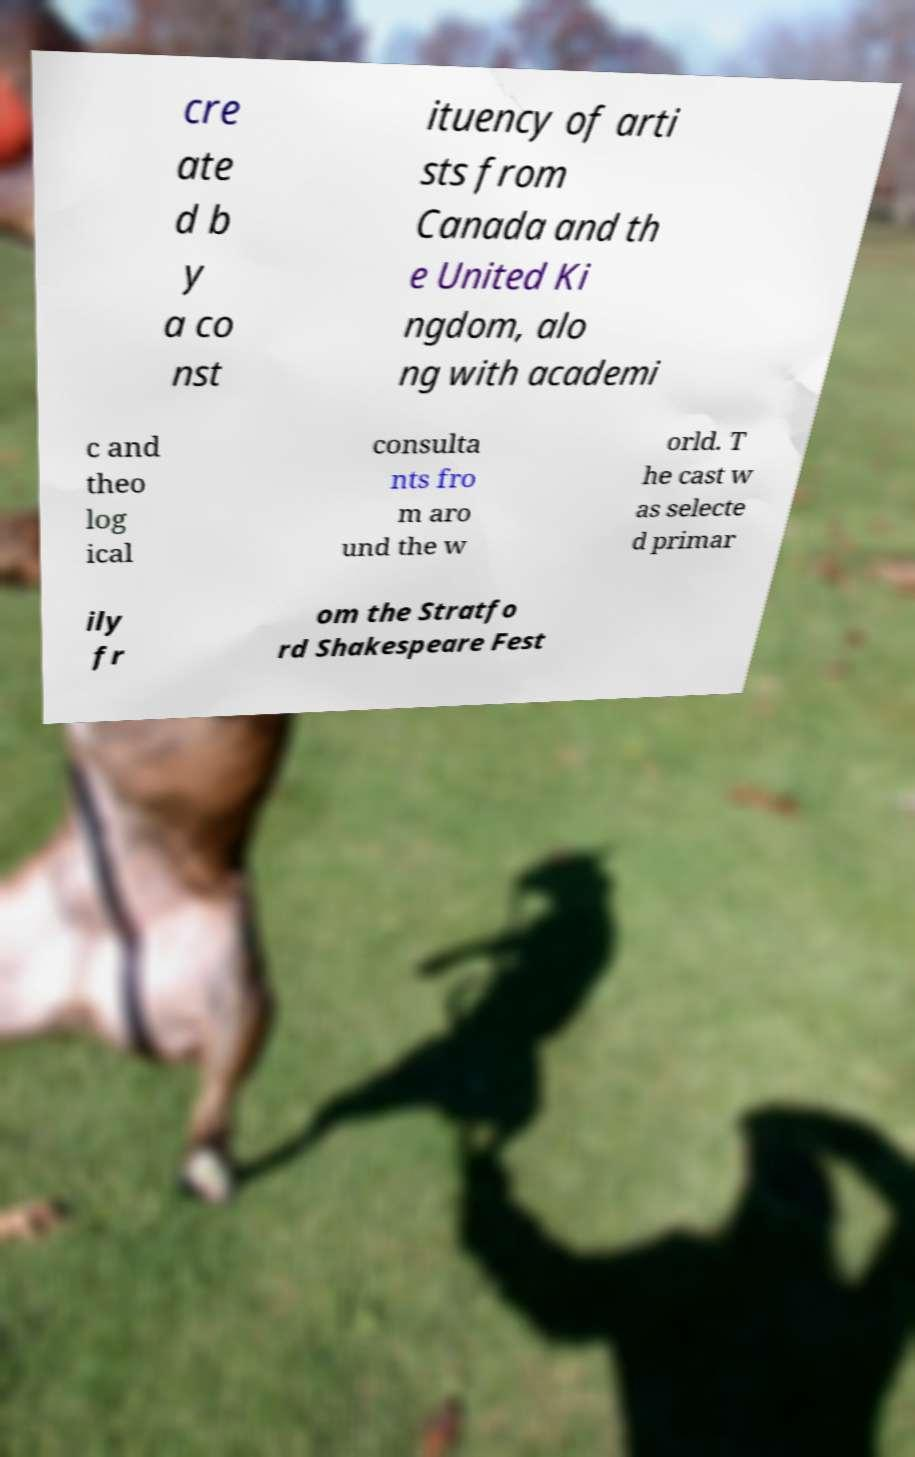Can you read and provide the text displayed in the image?This photo seems to have some interesting text. Can you extract and type it out for me? cre ate d b y a co nst ituency of arti sts from Canada and th e United Ki ngdom, alo ng with academi c and theo log ical consulta nts fro m aro und the w orld. T he cast w as selecte d primar ily fr om the Stratfo rd Shakespeare Fest 